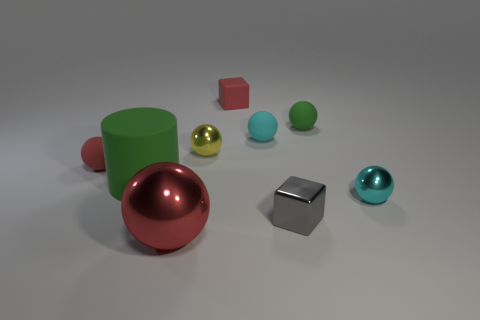There is a big metallic ball; is it the same color as the tiny metallic ball that is right of the yellow ball?
Keep it short and to the point. No. Are there any other things that have the same shape as the small cyan rubber thing?
Keep it short and to the point. Yes. There is a shiny ball that is on the right side of the small shiny sphere on the left side of the green rubber ball; what is its color?
Your response must be concise. Cyan. What number of cubes are there?
Ensure brevity in your answer.  2. How many matte things are small purple cylinders or small red things?
Provide a short and direct response. 2. What number of small matte blocks are the same color as the large metallic object?
Your answer should be compact. 1. There is a small cyan thing behind the metal thing that is behind the red rubber ball; what is it made of?
Ensure brevity in your answer.  Rubber. The gray metallic thing is what size?
Your answer should be very brief. Small. What number of green things have the same size as the cyan matte ball?
Offer a very short reply. 1. How many other objects are the same shape as the small gray thing?
Your response must be concise. 1. 